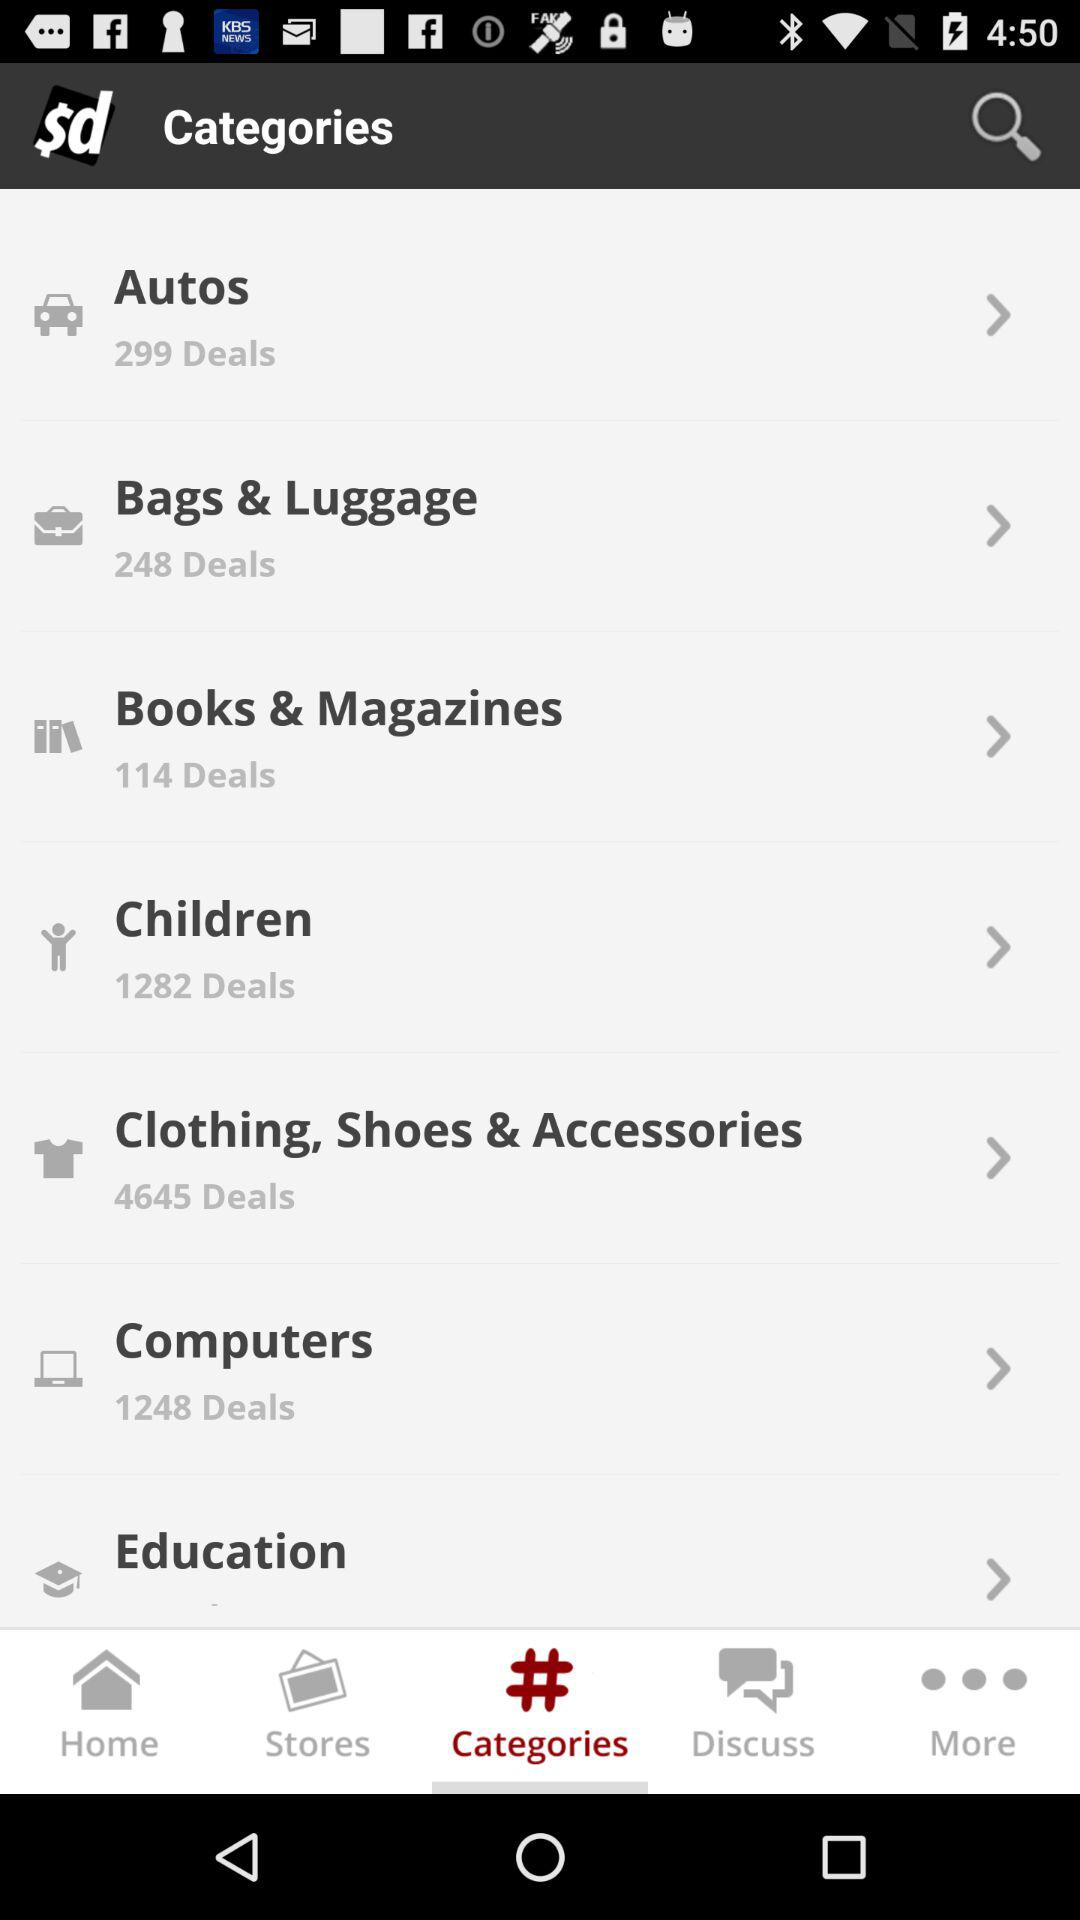How many deals are available for children? There are 1282 deals. 